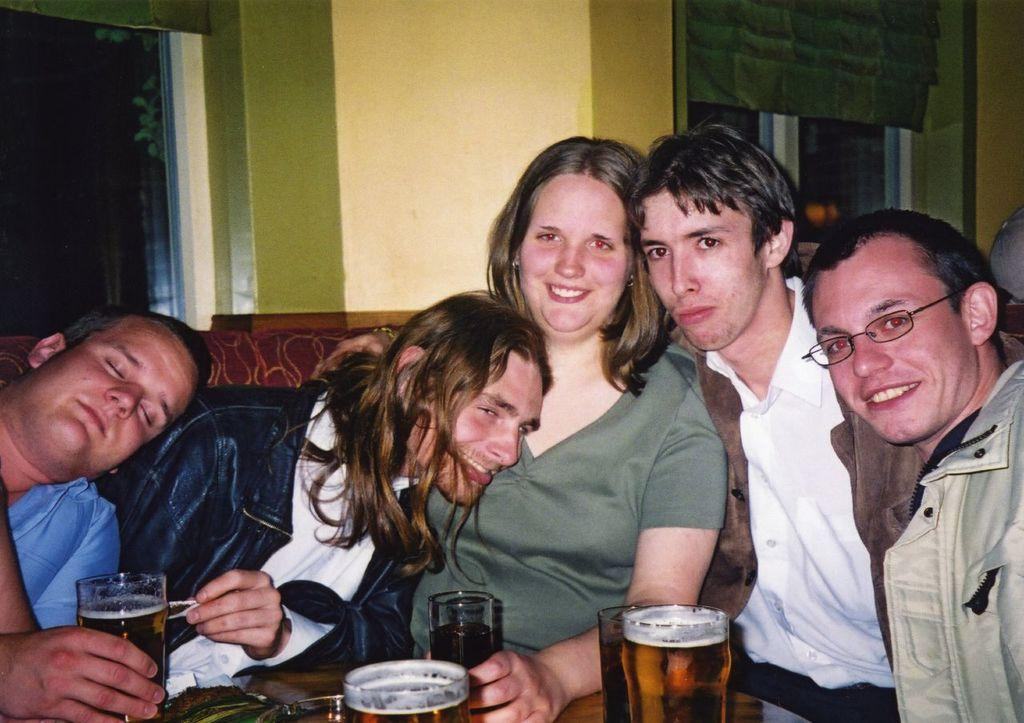What is happening in the image? There is a group of people in the image, and they are seated. What can be seen on the table in the image? There are glasses on the table in the image. What type of leaf is being used as a coaster for the glasses in the image? There is no leaf present in the image, and the glasses are not placed on any coasters. 